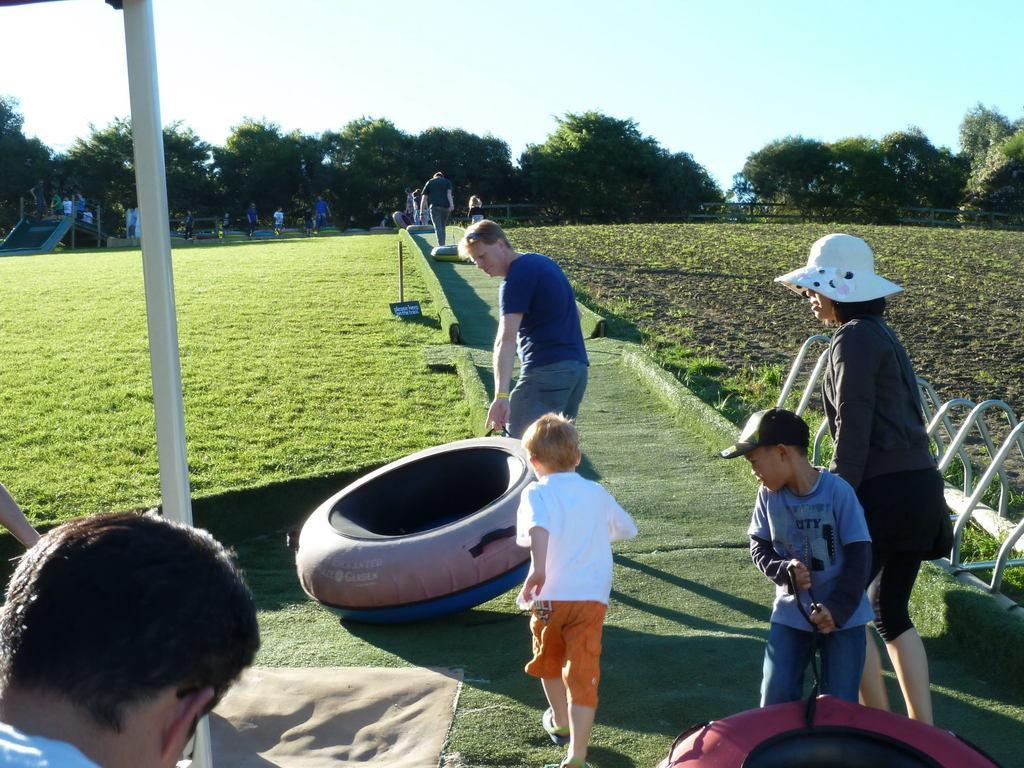Can you describe this image briefly? There is a person standing and holding an object in his hand and there are few other people behind him and the ground is greenery and there are trees in the background. 